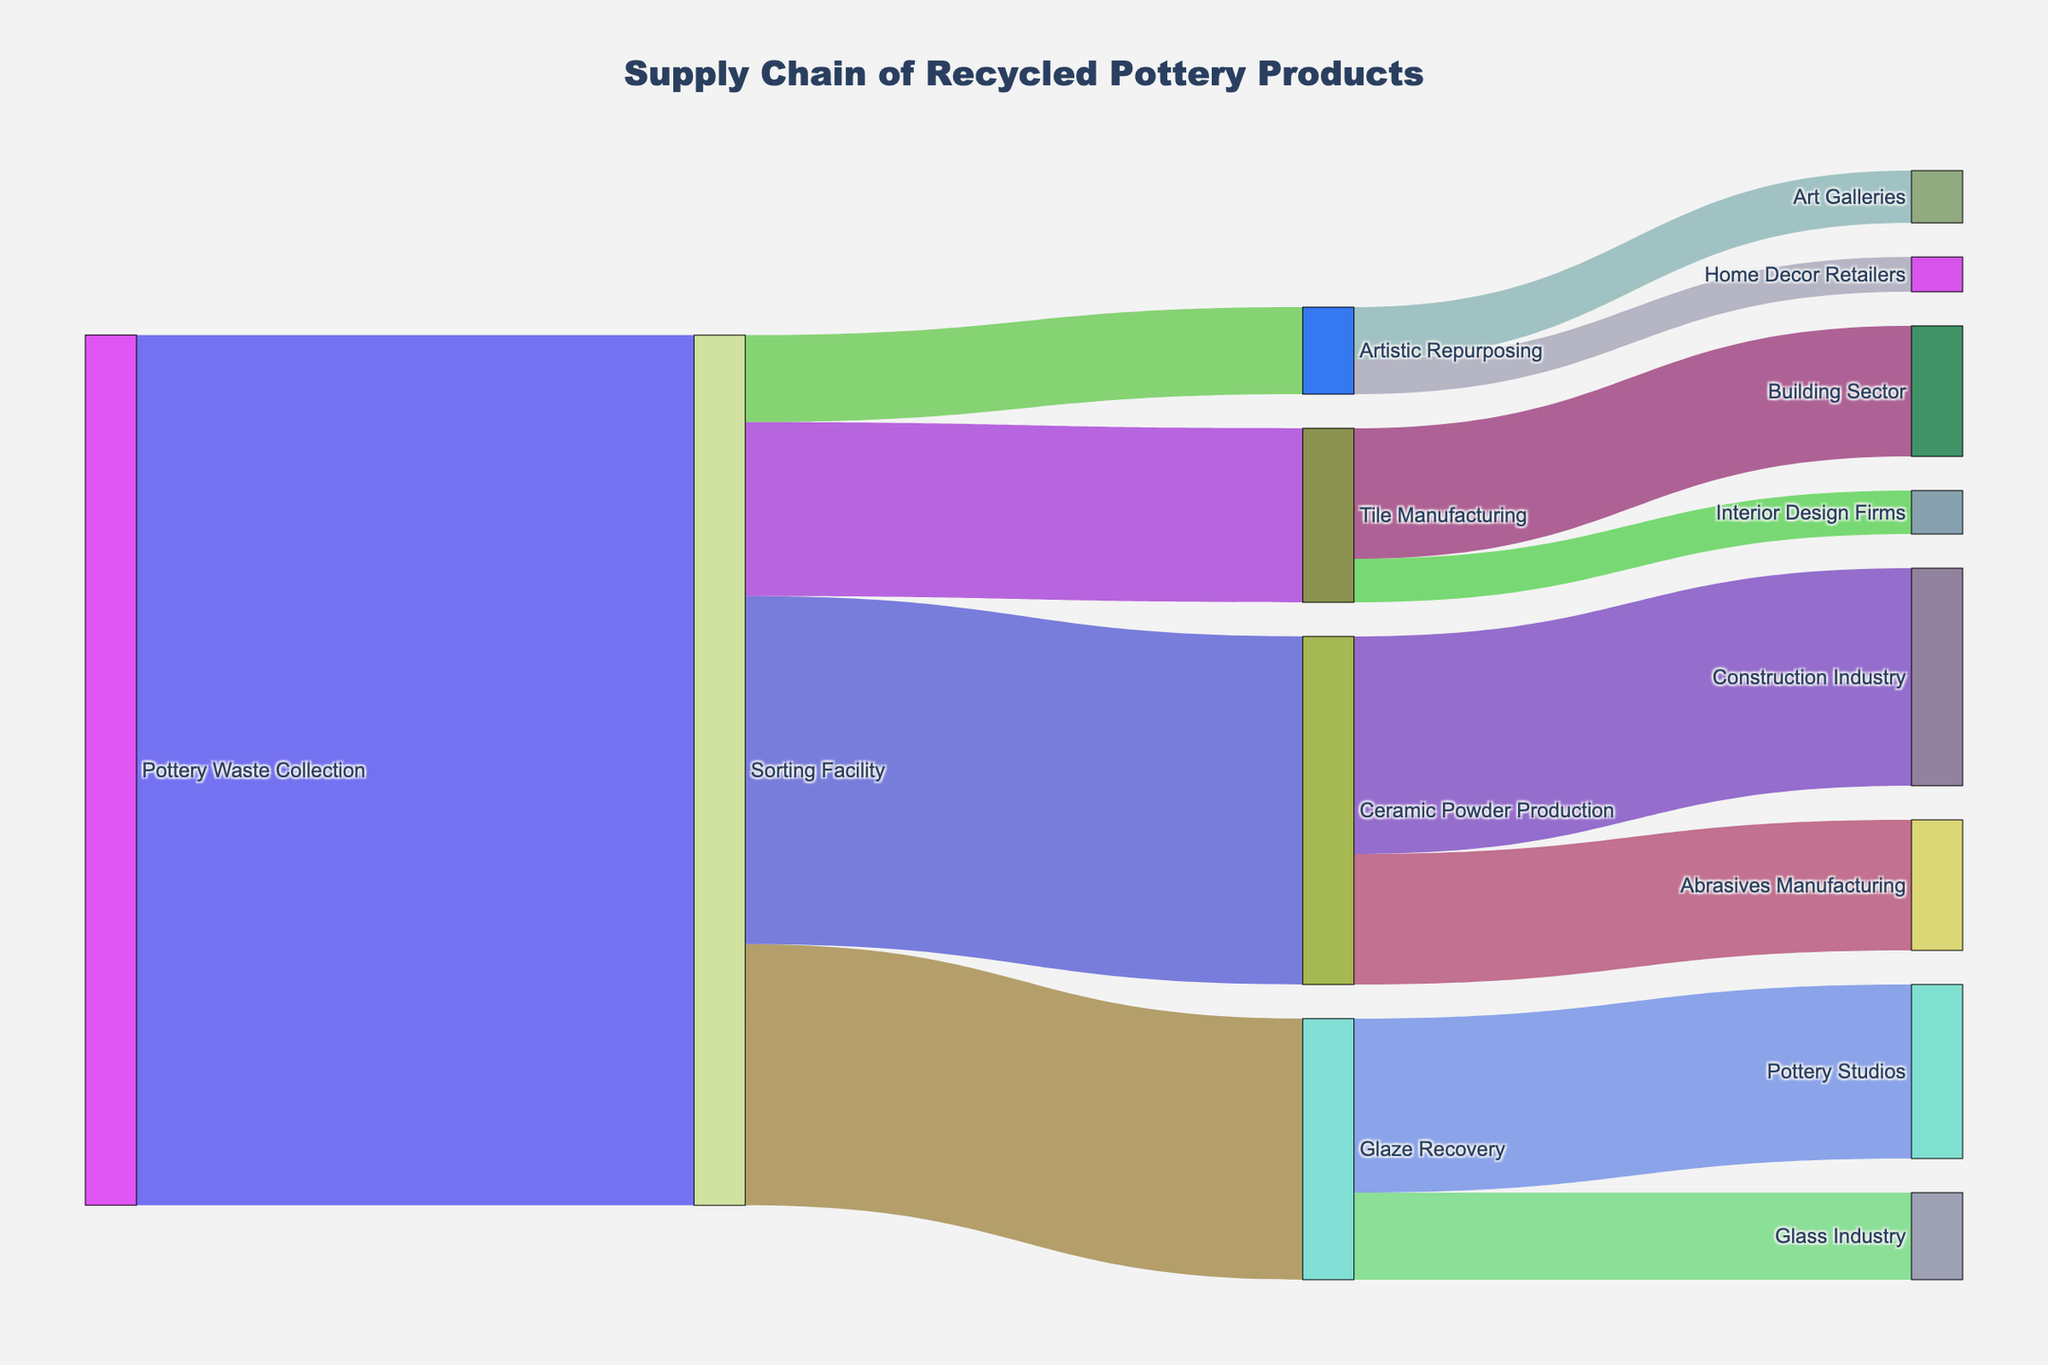What is the title of the Sankey diagram? The title of the diagram is located at the top and is usually larger or in bold. It helps in understanding what the diagram represents.
Answer: Supply Chain of Recycled Pottery Products Which path has the highest value from the Sorting Facility? Follow the outgoing paths from the Sorting Facility and compare the values. The largest value will indicate the path with the highest value.
Answer: Ceramic Powder Production (400) How much pottery waste is allocated to Glaze Recovery from the Sorting Facility? Look at the arrow connecting Sorting Facility to Glaze Recovery and find the value labeled on it.
Answer: 300 What is the total value directed to Tile Manufacturing, combining all sources? Sum the values of all arrows leading to Tile Manufacturing from any source. Here, it's only from Sorting Facility.
Answer: 200 How much pottery waste is directed to the Building Sector from Tile Manufacturing? Identify the arrow connecting Tile Manufacturing to the Building Sector and read the value labeled on it.
Answer: 150 What is the difference in value between the Construction Industry and Abrasives Manufacturing from the Ceramic Powder Production? Find the values connected to both the Construction Industry (250) and Abrasives Manufacturing (150) from Ceramic Powder Production and subtract the smaller value from the larger one.
Answer: 100 Which industry receives the smallest amount of pottery waste, based on the diagram? Compare all the values directed to different industries at the end, and find the smallest value among them.
Answer: Home Decor Retailers (40) How much total waste goes to all industries from Glaze Recovery? Sum up all values of the arrows originating from Glaze Recovery to different industries.
Answer: 300 (200 to Pottery Studios + 100 to Glass Industry) What is the combined total value of pottery waste used in the artistic repurposing and tile manufacturing routes? Sum the values of all arrows leading to artistic repurposing (100) and tile manufacturing (200) from the Sorting Facility.
Answer: 300 Which route has a higher value: Pottery Waste Collection to Ceramic Powder Production or Pottery Waste Collection to Glaze Recovery? Compare the values of the paths from Pottery Waste Collection to Ceramic Powder Production (400) and Glaze Recovery (300). The higher value determines the answer.
Answer: Ceramic Powder Production (400) 